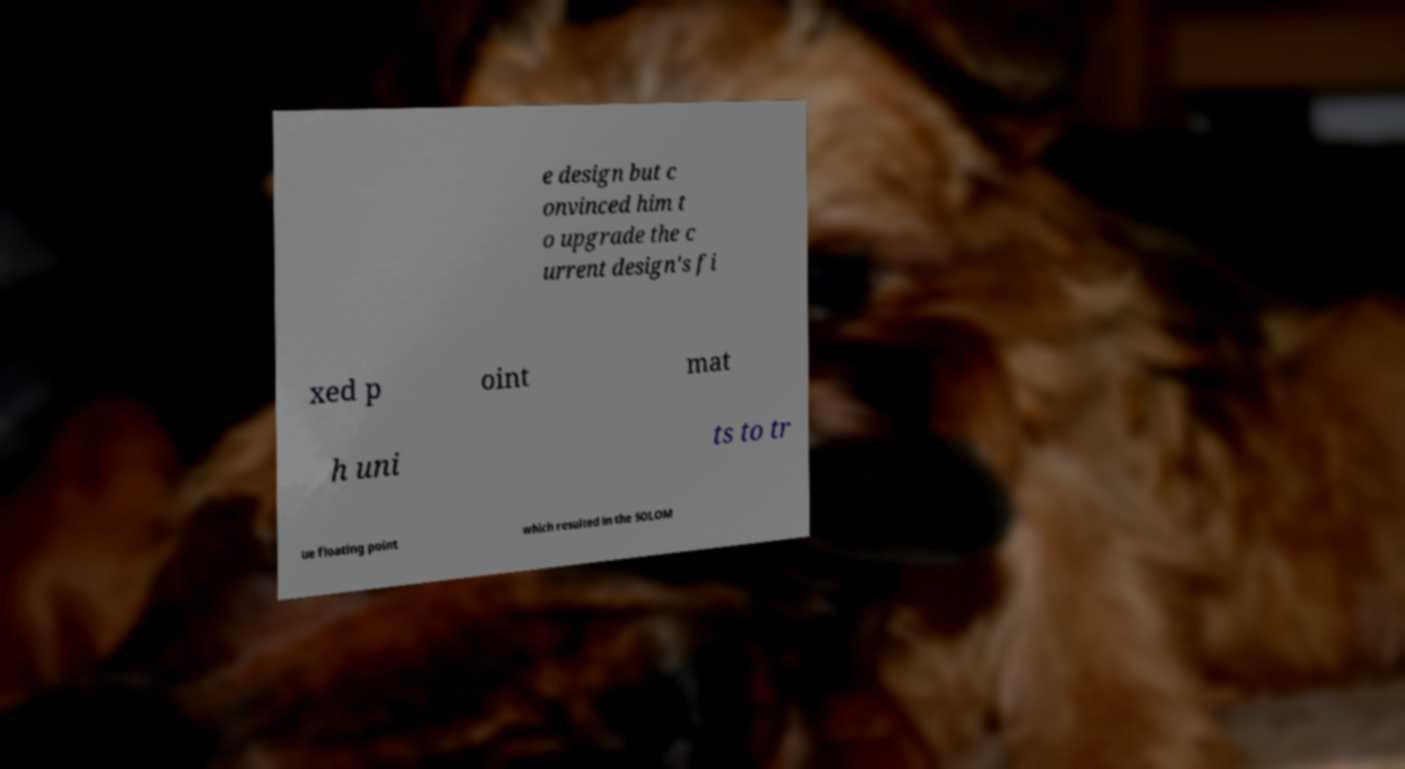Could you extract and type out the text from this image? e design but c onvinced him t o upgrade the c urrent design's fi xed p oint mat h uni ts to tr ue floating point which resulted in the SOLOM 